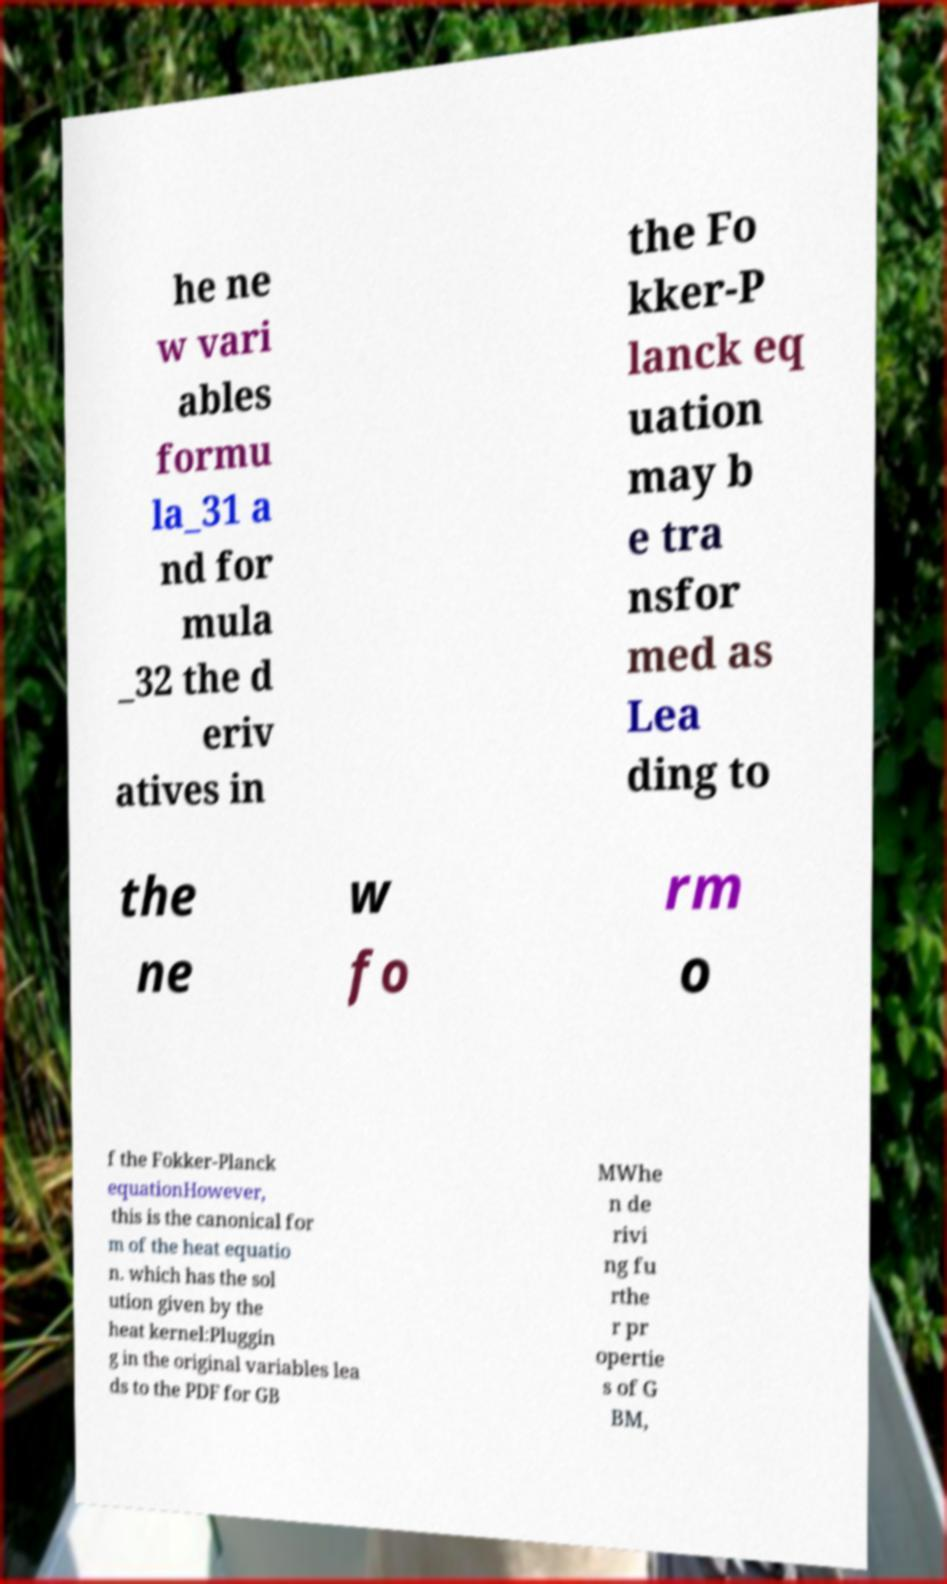Can you read and provide the text displayed in the image?This photo seems to have some interesting text. Can you extract and type it out for me? he ne w vari ables formu la_31 a nd for mula _32 the d eriv atives in the Fo kker-P lanck eq uation may b e tra nsfor med as Lea ding to the ne w fo rm o f the Fokker-Planck equationHowever, this is the canonical for m of the heat equatio n. which has the sol ution given by the heat kernel:Pluggin g in the original variables lea ds to the PDF for GB MWhe n de rivi ng fu rthe r pr opertie s of G BM, 